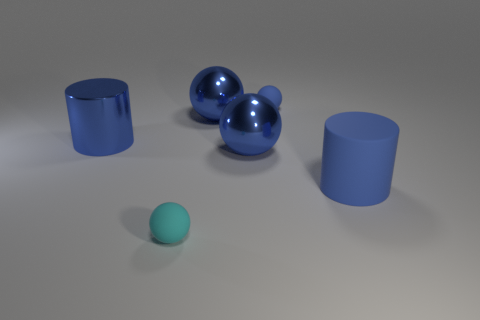Add 3 large blue shiny cylinders. How many objects exist? 9 Subtract all cylinders. How many objects are left? 4 Subtract 1 cylinders. How many cylinders are left? 1 Subtract all cyan spheres. How many spheres are left? 3 Subtract 0 blue blocks. How many objects are left? 6 Subtract all red spheres. Subtract all gray cylinders. How many spheres are left? 4 Subtract all purple cylinders. How many cyan balls are left? 1 Subtract all small metallic cylinders. Subtract all large matte things. How many objects are left? 5 Add 4 big blue matte cylinders. How many big blue matte cylinders are left? 5 Add 4 small objects. How many small objects exist? 6 